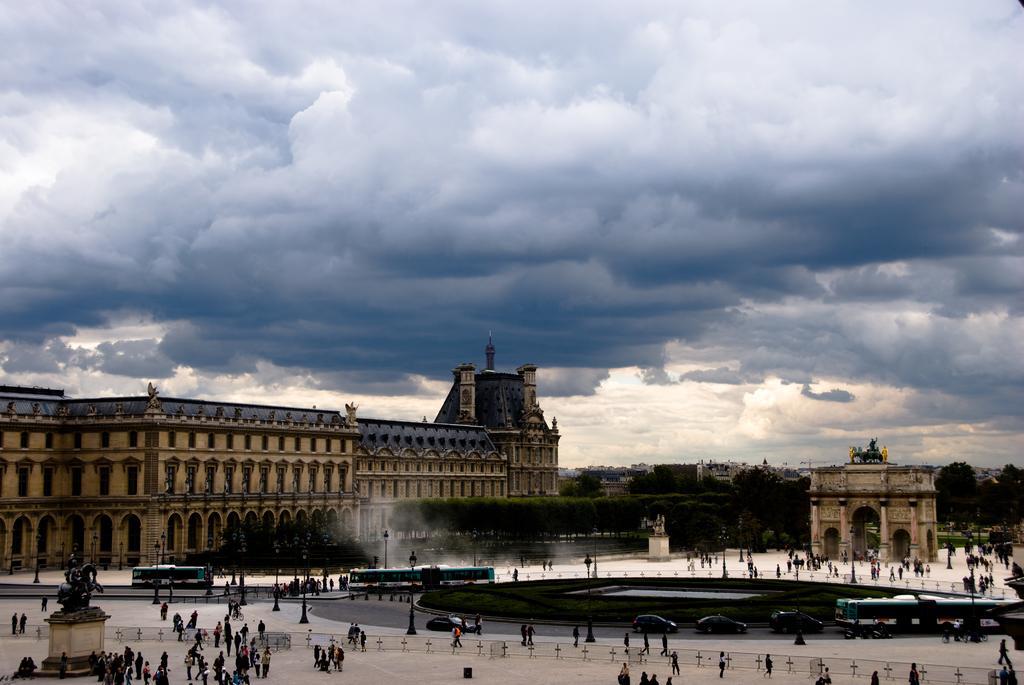Could you give a brief overview of what you see in this image? This is an outside view. At the bottom, I can see many people walking on the ground and there are many buildings and trees. On the left side there is a statue on a pillar. On the right side there are few vehicles on the road. At the top of the image I can see the sky and clouds. 